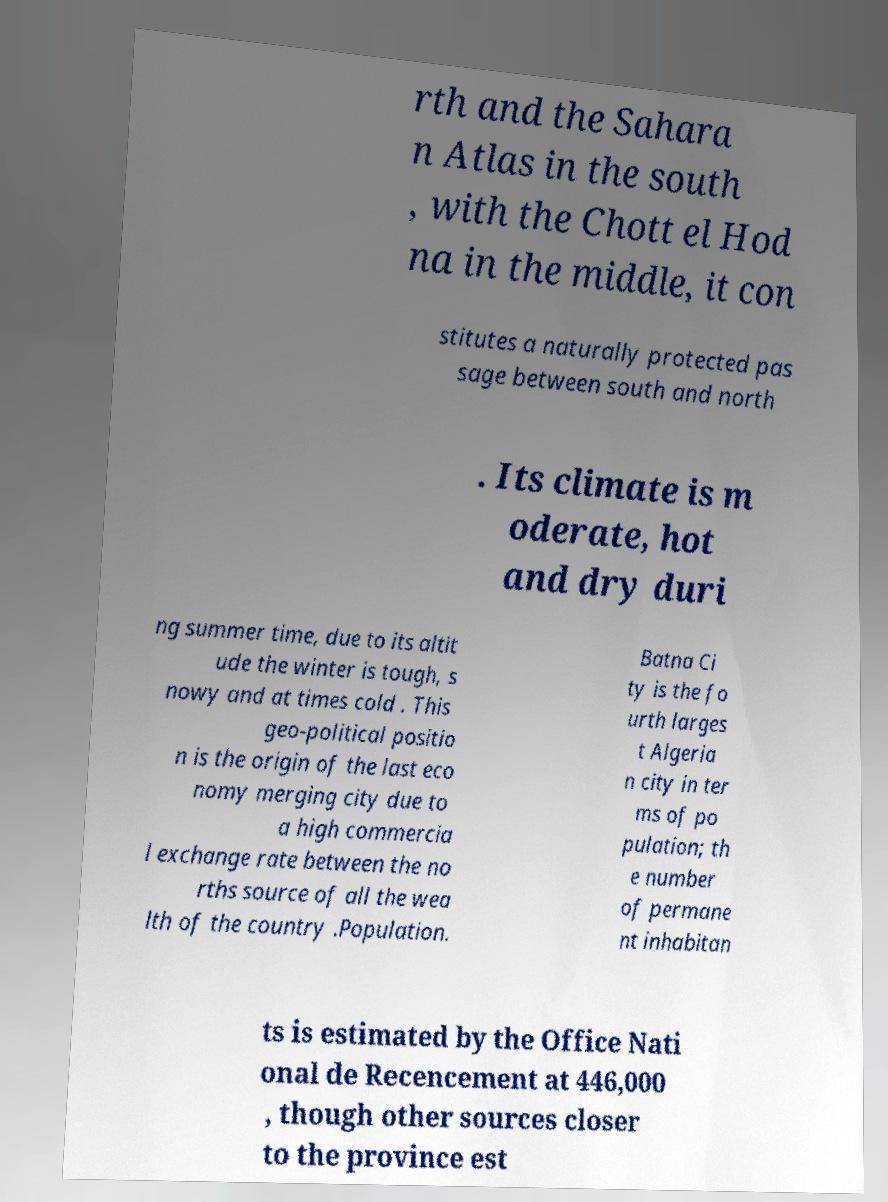What messages or text are displayed in this image? I need them in a readable, typed format. rth and the Sahara n Atlas in the south , with the Chott el Hod na in the middle, it con stitutes a naturally protected pas sage between south and north . Its climate is m oderate, hot and dry duri ng summer time, due to its altit ude the winter is tough, s nowy and at times cold . This geo-political positio n is the origin of the last eco nomy merging city due to a high commercia l exchange rate between the no rths source of all the wea lth of the country .Population. Batna Ci ty is the fo urth larges t Algeria n city in ter ms of po pulation; th e number of permane nt inhabitan ts is estimated by the Office Nati onal de Recencement at 446,000 , though other sources closer to the province est 